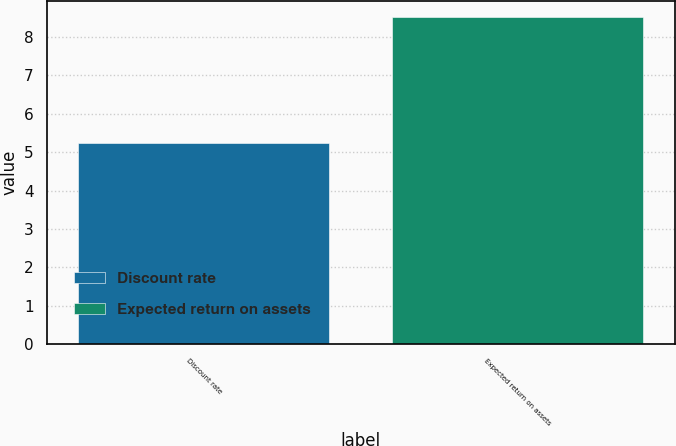Convert chart to OTSL. <chart><loc_0><loc_0><loc_500><loc_500><bar_chart><fcel>Discount rate<fcel>Expected return on assets<nl><fcel>5.23<fcel>8.5<nl></chart> 